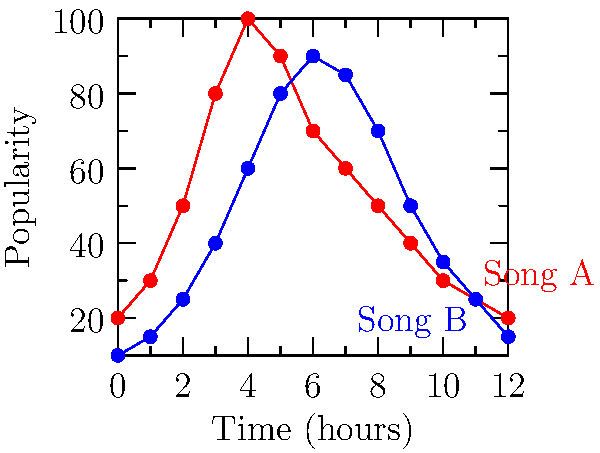You're creating a playlist for your high school radio show. The graph shows the popularity of two songs over a 12-hour period. If you want to maximize the total popularity when playing both songs once, at what times should you schedule Song A and Song B? Let's approach this step-by-step:

1) First, we need to identify the peak popularity for each song:
   - Song A (red) peaks at hour 4 with a popularity of 100
   - Song B (blue) peaks at hour 6 with a popularity of 90

2) To maximize total popularity, we should play each song at or near its peak.

3) We can't play both songs at the same time, so we need to choose the best combination:
   - Option 1: Play Song A at hour 4 (100) and Song B at hour 7 (85)
   - Option 2: Play Song A at hour 5 (90) and Song B at hour 6 (90)

4) Let's calculate the total popularity for each option:
   - Option 1: 100 + 85 = 185
   - Option 2: 90 + 90 = 180

5) Option 1 gives us a higher total popularity of 185.

Therefore, to maximize total popularity, we should play Song A at hour 4 and Song B at hour 7.
Answer: Song A at hour 4, Song B at hour 7 